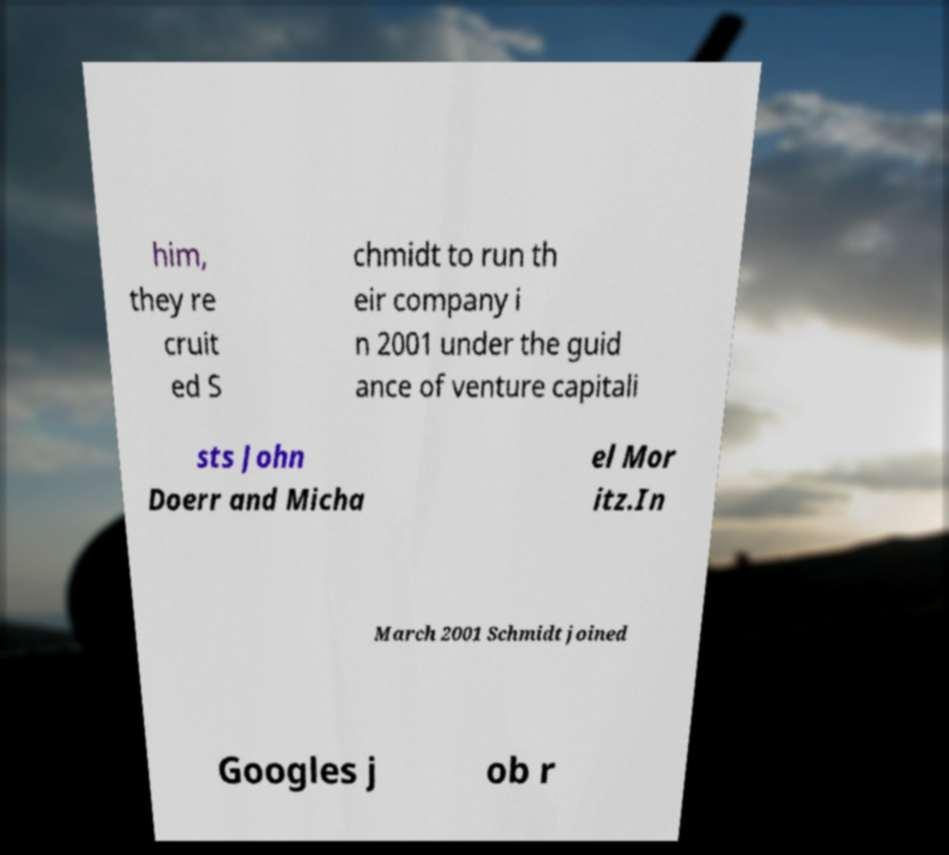What messages or text are displayed in this image? I need them in a readable, typed format. him, they re cruit ed S chmidt to run th eir company i n 2001 under the guid ance of venture capitali sts John Doerr and Micha el Mor itz.In March 2001 Schmidt joined Googles j ob r 